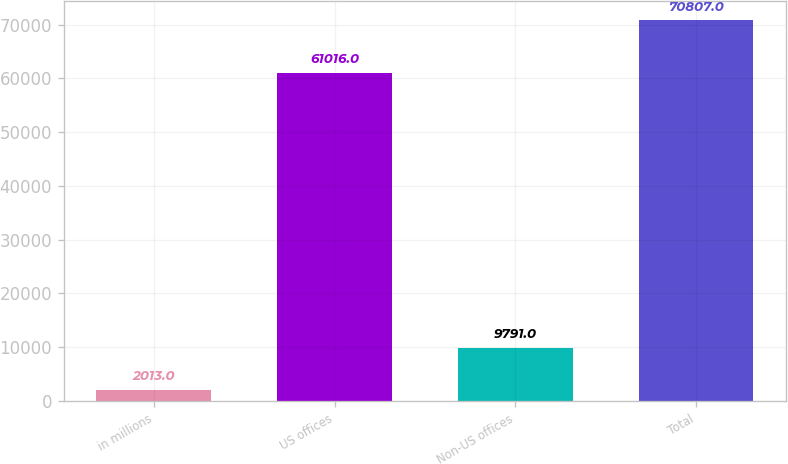Convert chart to OTSL. <chart><loc_0><loc_0><loc_500><loc_500><bar_chart><fcel>in millions<fcel>US offices<fcel>Non-US offices<fcel>Total<nl><fcel>2013<fcel>61016<fcel>9791<fcel>70807<nl></chart> 